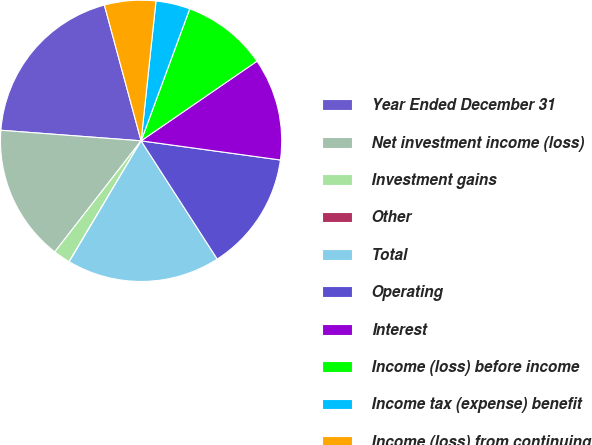<chart> <loc_0><loc_0><loc_500><loc_500><pie_chart><fcel>Year Ended December 31<fcel>Net investment income (loss)<fcel>Investment gains<fcel>Other<fcel>Total<fcel>Operating<fcel>Interest<fcel>Income (loss) before income<fcel>Income tax (expense) benefit<fcel>Income (loss) from continuing<nl><fcel>19.6%<fcel>15.68%<fcel>1.97%<fcel>0.01%<fcel>17.64%<fcel>13.72%<fcel>11.76%<fcel>9.8%<fcel>3.93%<fcel>5.89%<nl></chart> 